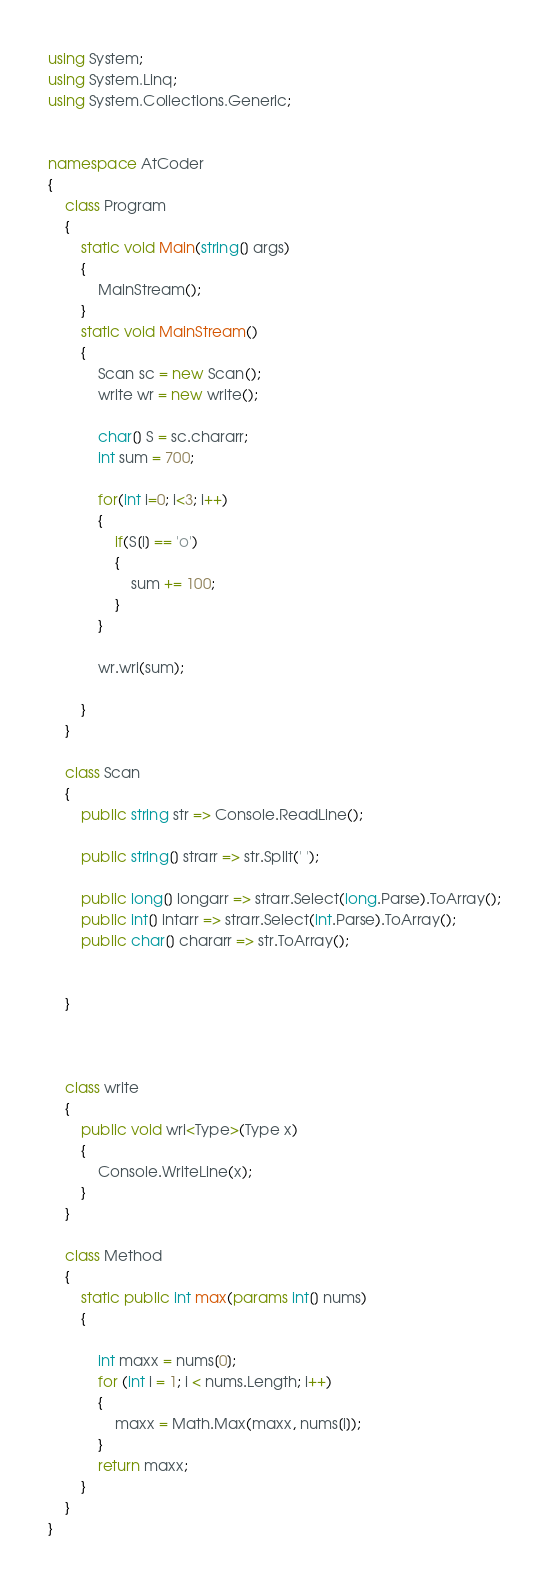<code> <loc_0><loc_0><loc_500><loc_500><_C#_>using System;
using System.Linq;
using System.Collections.Generic;


namespace AtCoder
{
    class Program
    {
        static void Main(string[] args)
        {
            MainStream();
        }
        static void MainStream()
        {
            Scan sc = new Scan();
            write wr = new write();

            char[] S = sc.chararr;
            int sum = 700;

            for(int i=0; i<3; i++)
            {
                if(S[i] == 'o')
                {
                    sum += 100;
                }
            }

            wr.wri(sum);

        }
    }

    class Scan
    {
        public string str => Console.ReadLine();

        public string[] strarr => str.Split(' ');

        public long[] longarr => strarr.Select(long.Parse).ToArray();
        public int[] intarr => strarr.Select(int.Parse).ToArray();
        public char[] chararr => str.ToArray();


    }



    class write
    {
        public void wri<Type>(Type x)
        {
            Console.WriteLine(x);
        }
    }

    class Method
    {
        static public int max(params int[] nums)
        {

            int maxx = nums[0];
            for (int i = 1; i < nums.Length; i++)
            {
                maxx = Math.Max(maxx, nums[i]);
            }
            return maxx;
        }
    }
}
</code> 